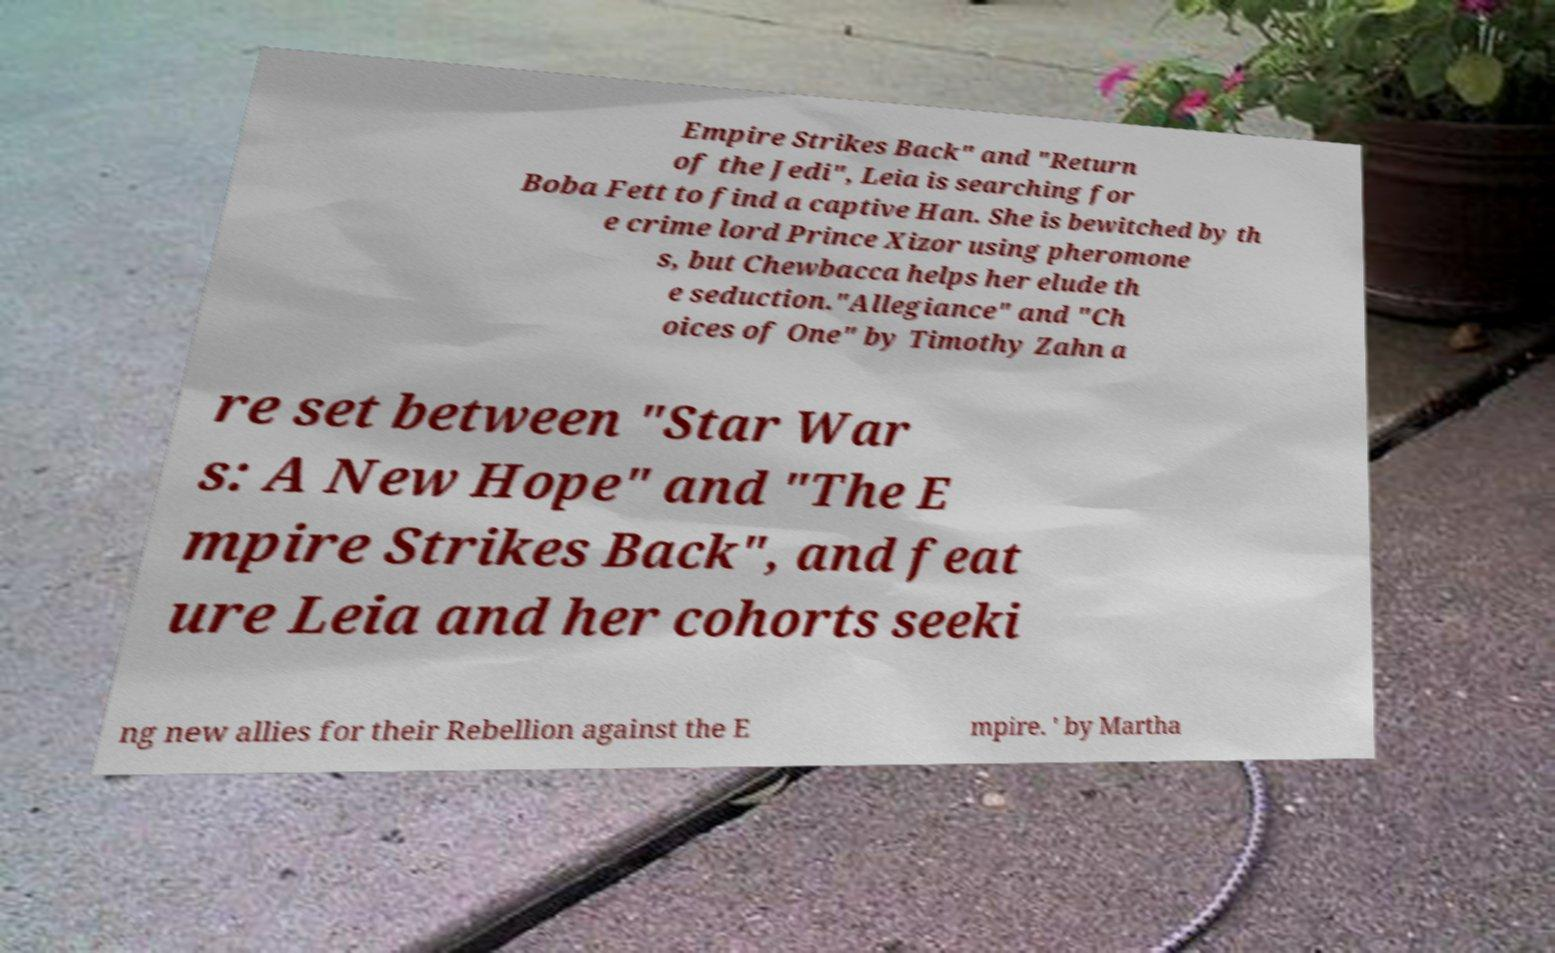Can you read and provide the text displayed in the image?This photo seems to have some interesting text. Can you extract and type it out for me? Empire Strikes Back" and "Return of the Jedi", Leia is searching for Boba Fett to find a captive Han. She is bewitched by th e crime lord Prince Xizor using pheromone s, but Chewbacca helps her elude th e seduction."Allegiance" and "Ch oices of One" by Timothy Zahn a re set between "Star War s: A New Hope" and "The E mpire Strikes Back", and feat ure Leia and her cohorts seeki ng new allies for their Rebellion against the E mpire. ' by Martha 